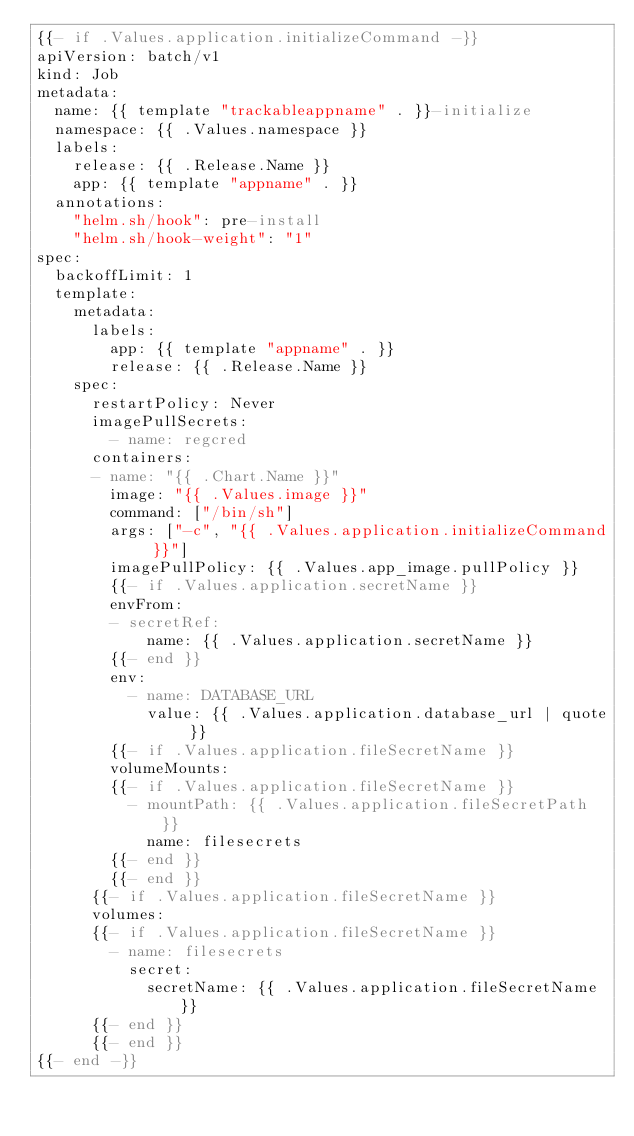<code> <loc_0><loc_0><loc_500><loc_500><_YAML_>{{- if .Values.application.initializeCommand -}}
apiVersion: batch/v1
kind: Job
metadata:
  name: {{ template "trackableappname" . }}-initialize
  namespace: {{ .Values.namespace }}
  labels:
    release: {{ .Release.Name }}
    app: {{ template "appname" . }}
  annotations:
    "helm.sh/hook": pre-install
    "helm.sh/hook-weight": "1"
spec:
  backoffLimit: 1
  template:
    metadata:
      labels:
        app: {{ template "appname" . }}
        release: {{ .Release.Name }}
    spec:
      restartPolicy: Never
      imagePullSecrets:
        - name: regcred
      containers:
      - name: "{{ .Chart.Name }}"
        image: "{{ .Values.image }}"
        command: ["/bin/sh"]
        args: ["-c", "{{ .Values.application.initializeCommand }}"]
        imagePullPolicy: {{ .Values.app_image.pullPolicy }}
        {{- if .Values.application.secretName }}
        envFrom:
        - secretRef:
            name: {{ .Values.application.secretName }}
        {{- end }}
        env:
          - name: DATABASE_URL
            value: {{ .Values.application.database_url | quote }}
        {{- if .Values.application.fileSecretName }}
        volumeMounts:
        {{- if .Values.application.fileSecretName }}
          - mountPath: {{ .Values.application.fileSecretPath }}
            name: filesecrets
        {{- end }}
        {{- end }}
      {{- if .Values.application.fileSecretName }}
      volumes:
      {{- if .Values.application.fileSecretName }}
        - name: filesecrets
          secret:
            secretName: {{ .Values.application.fileSecretName }}
      {{- end }}
      {{- end }}
{{- end -}}
</code> 